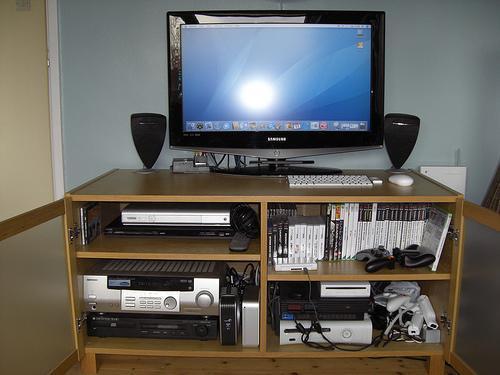How many screens are visible?
Give a very brief answer. 1. 